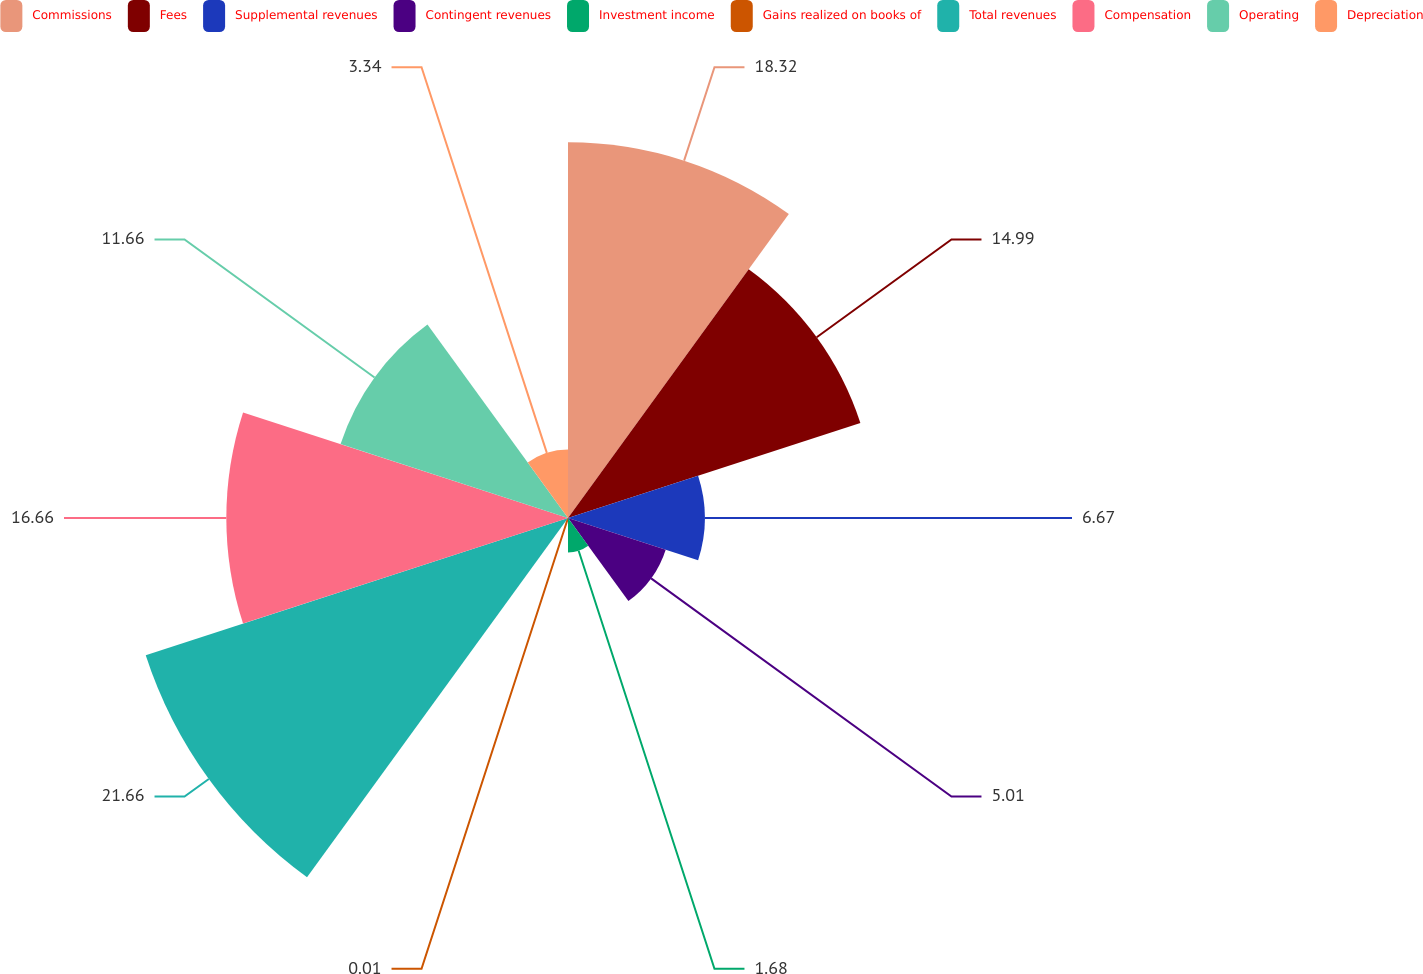<chart> <loc_0><loc_0><loc_500><loc_500><pie_chart><fcel>Commissions<fcel>Fees<fcel>Supplemental revenues<fcel>Contingent revenues<fcel>Investment income<fcel>Gains realized on books of<fcel>Total revenues<fcel>Compensation<fcel>Operating<fcel>Depreciation<nl><fcel>18.32%<fcel>14.99%<fcel>6.67%<fcel>5.01%<fcel>1.68%<fcel>0.01%<fcel>21.65%<fcel>16.66%<fcel>11.66%<fcel>3.34%<nl></chart> 